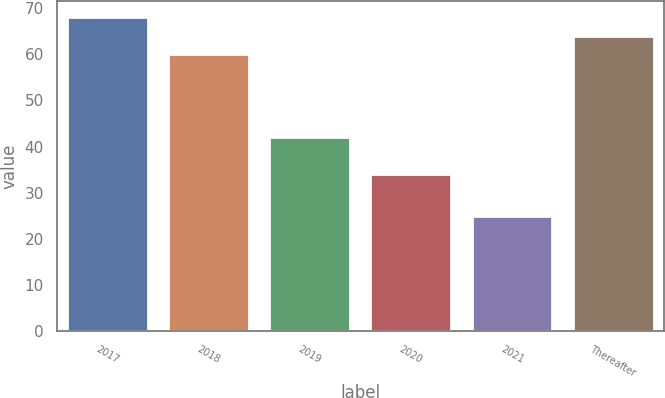Convert chart. <chart><loc_0><loc_0><loc_500><loc_500><bar_chart><fcel>2017<fcel>2018<fcel>2019<fcel>2020<fcel>2021<fcel>Thereafter<nl><fcel>68.2<fcel>60<fcel>42<fcel>34<fcel>25<fcel>64.1<nl></chart> 